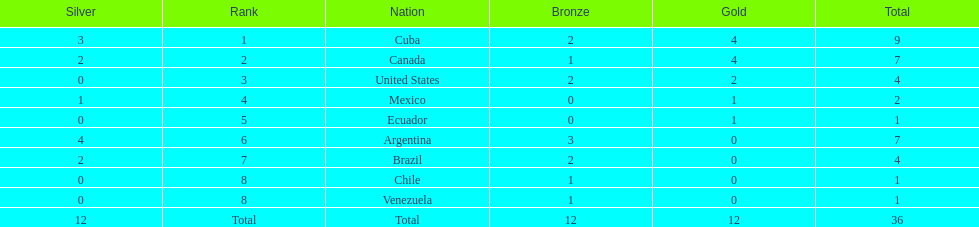How many total medals did brazil received? 4. 